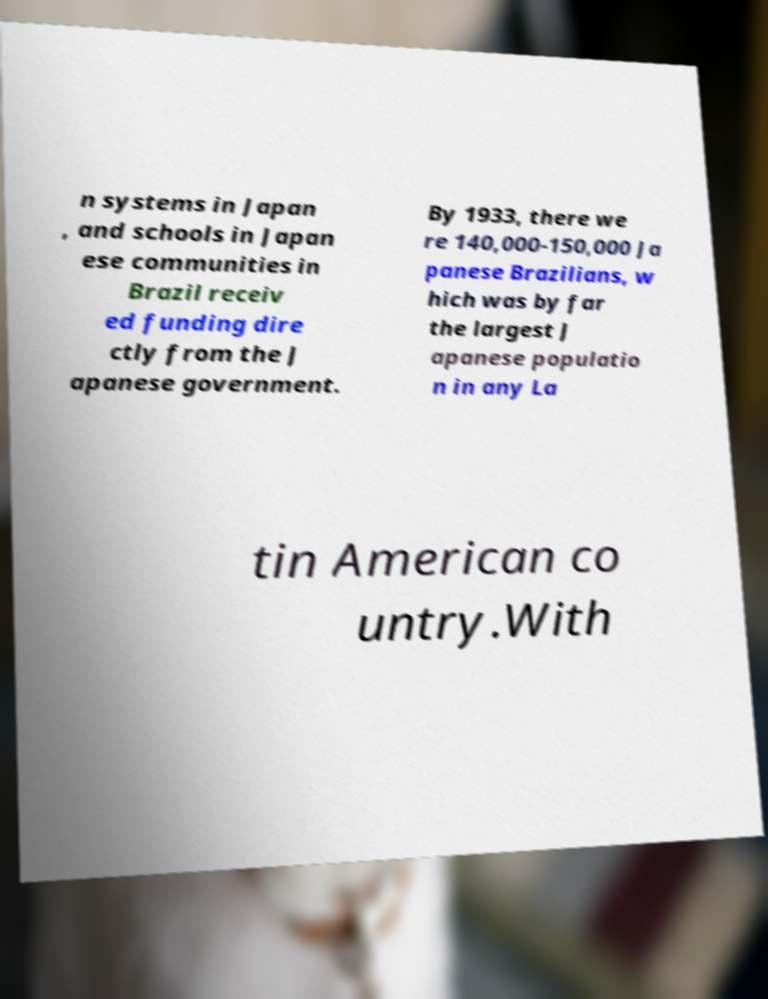Could you assist in decoding the text presented in this image and type it out clearly? n systems in Japan , and schools in Japan ese communities in Brazil receiv ed funding dire ctly from the J apanese government. By 1933, there we re 140,000-150,000 Ja panese Brazilians, w hich was by far the largest J apanese populatio n in any La tin American co untry.With 